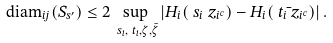Convert formula to latex. <formula><loc_0><loc_0><loc_500><loc_500>& \text {diam} _ { i j } ( S _ { s ^ { \prime } } ) \leq 2 \sup _ { \ s _ { i } , \ t _ { i } , \zeta , \bar { \zeta } } \left | H _ { i } ( \ s _ { i } \ z _ { i ^ { c } } ) - H _ { i } ( \ t _ { i } \bar { \ } z _ { i ^ { c } } ) \right | .</formula> 